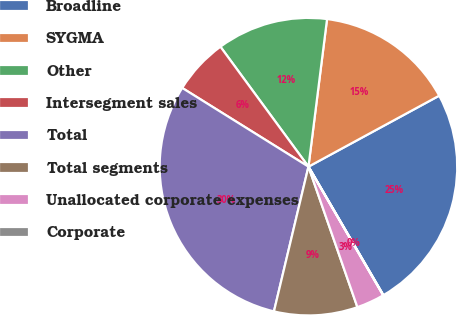<chart> <loc_0><loc_0><loc_500><loc_500><pie_chart><fcel>Broadline<fcel>SYGMA<fcel>Other<fcel>Intersegment sales<fcel>Total<fcel>Total segments<fcel>Unallocated corporate expenses<fcel>Corporate<nl><fcel>24.51%<fcel>15.09%<fcel>12.07%<fcel>6.05%<fcel>30.15%<fcel>9.06%<fcel>3.04%<fcel>0.03%<nl></chart> 